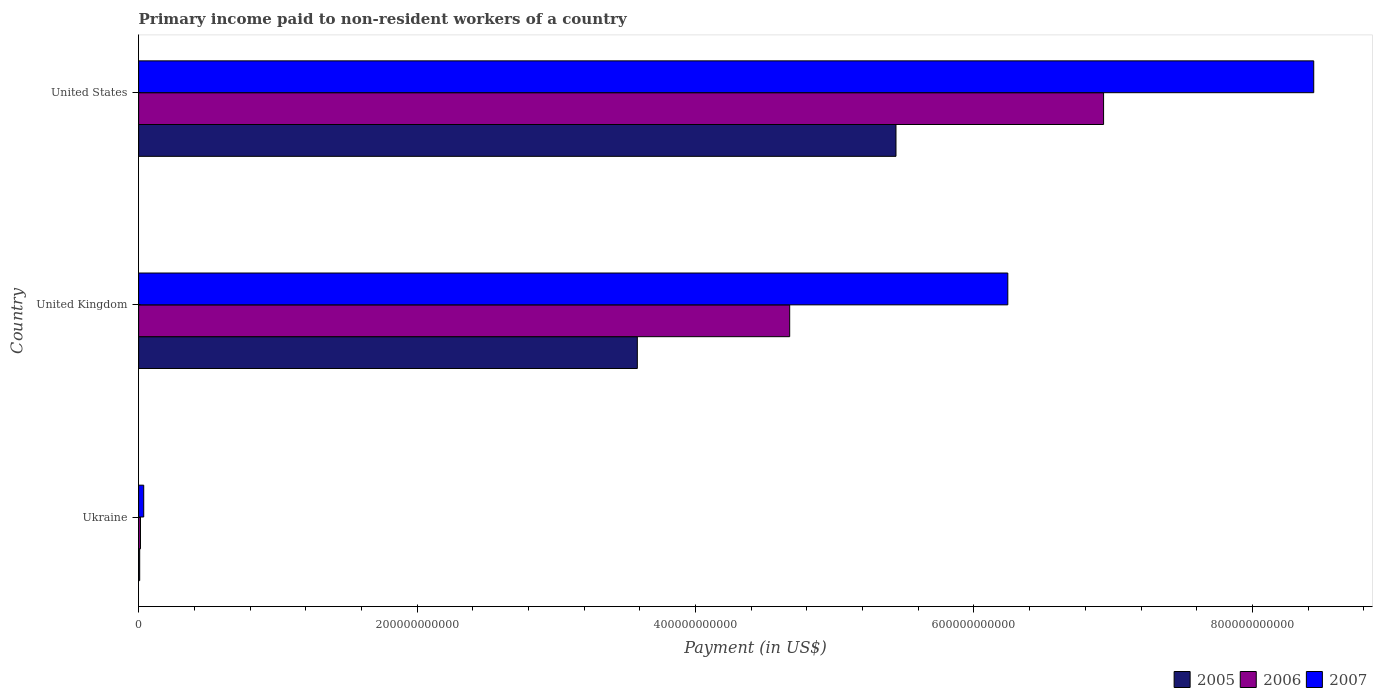How many different coloured bars are there?
Keep it short and to the point. 3. How many groups of bars are there?
Provide a short and direct response. 3. What is the label of the 2nd group of bars from the top?
Offer a very short reply. United Kingdom. What is the amount paid to workers in 2007 in United Kingdom?
Offer a terse response. 6.24e+11. Across all countries, what is the maximum amount paid to workers in 2007?
Your response must be concise. 8.44e+11. Across all countries, what is the minimum amount paid to workers in 2005?
Offer a terse response. 7.58e+08. In which country was the amount paid to workers in 2005 maximum?
Your answer should be compact. United States. In which country was the amount paid to workers in 2005 minimum?
Offer a very short reply. Ukraine. What is the total amount paid to workers in 2006 in the graph?
Make the answer very short. 1.16e+12. What is the difference between the amount paid to workers in 2006 in Ukraine and that in United Kingdom?
Your response must be concise. -4.66e+11. What is the difference between the amount paid to workers in 2007 in United Kingdom and the amount paid to workers in 2006 in Ukraine?
Make the answer very short. 6.23e+11. What is the average amount paid to workers in 2005 per country?
Provide a succinct answer. 3.01e+11. What is the difference between the amount paid to workers in 2006 and amount paid to workers in 2005 in Ukraine?
Offer a terse response. 5.74e+08. In how many countries, is the amount paid to workers in 2006 greater than 440000000000 US$?
Make the answer very short. 2. What is the ratio of the amount paid to workers in 2006 in United Kingdom to that in United States?
Provide a succinct answer. 0.67. Is the amount paid to workers in 2007 in Ukraine less than that in United States?
Make the answer very short. Yes. What is the difference between the highest and the second highest amount paid to workers in 2005?
Ensure brevity in your answer.  1.86e+11. What is the difference between the highest and the lowest amount paid to workers in 2007?
Provide a short and direct response. 8.40e+11. In how many countries, is the amount paid to workers in 2005 greater than the average amount paid to workers in 2005 taken over all countries?
Ensure brevity in your answer.  2. What does the 3rd bar from the top in United Kingdom represents?
Keep it short and to the point. 2005. What does the 3rd bar from the bottom in United Kingdom represents?
Offer a very short reply. 2007. Are all the bars in the graph horizontal?
Your response must be concise. Yes. How many countries are there in the graph?
Give a very brief answer. 3. What is the difference between two consecutive major ticks on the X-axis?
Give a very brief answer. 2.00e+11. Are the values on the major ticks of X-axis written in scientific E-notation?
Offer a very short reply. No. Does the graph contain grids?
Make the answer very short. No. Where does the legend appear in the graph?
Your answer should be compact. Bottom right. How many legend labels are there?
Provide a short and direct response. 3. How are the legend labels stacked?
Ensure brevity in your answer.  Horizontal. What is the title of the graph?
Give a very brief answer. Primary income paid to non-resident workers of a country. Does "1965" appear as one of the legend labels in the graph?
Offer a terse response. No. What is the label or title of the X-axis?
Give a very brief answer. Payment (in US$). What is the Payment (in US$) of 2005 in Ukraine?
Give a very brief answer. 7.58e+08. What is the Payment (in US$) of 2006 in Ukraine?
Offer a very short reply. 1.33e+09. What is the Payment (in US$) in 2007 in Ukraine?
Offer a terse response. 3.66e+09. What is the Payment (in US$) in 2005 in United Kingdom?
Your response must be concise. 3.58e+11. What is the Payment (in US$) in 2006 in United Kingdom?
Offer a terse response. 4.68e+11. What is the Payment (in US$) in 2007 in United Kingdom?
Offer a very short reply. 6.24e+11. What is the Payment (in US$) of 2005 in United States?
Your answer should be compact. 5.44e+11. What is the Payment (in US$) in 2006 in United States?
Keep it short and to the point. 6.93e+11. What is the Payment (in US$) of 2007 in United States?
Give a very brief answer. 8.44e+11. Across all countries, what is the maximum Payment (in US$) of 2005?
Your answer should be compact. 5.44e+11. Across all countries, what is the maximum Payment (in US$) in 2006?
Your response must be concise. 6.93e+11. Across all countries, what is the maximum Payment (in US$) of 2007?
Offer a terse response. 8.44e+11. Across all countries, what is the minimum Payment (in US$) in 2005?
Provide a succinct answer. 7.58e+08. Across all countries, what is the minimum Payment (in US$) of 2006?
Provide a short and direct response. 1.33e+09. Across all countries, what is the minimum Payment (in US$) in 2007?
Your answer should be compact. 3.66e+09. What is the total Payment (in US$) of 2005 in the graph?
Your response must be concise. 9.03e+11. What is the total Payment (in US$) of 2006 in the graph?
Make the answer very short. 1.16e+12. What is the total Payment (in US$) of 2007 in the graph?
Ensure brevity in your answer.  1.47e+12. What is the difference between the Payment (in US$) of 2005 in Ukraine and that in United Kingdom?
Ensure brevity in your answer.  -3.57e+11. What is the difference between the Payment (in US$) in 2006 in Ukraine and that in United Kingdom?
Provide a succinct answer. -4.66e+11. What is the difference between the Payment (in US$) in 2007 in Ukraine and that in United Kingdom?
Your answer should be very brief. -6.21e+11. What is the difference between the Payment (in US$) of 2005 in Ukraine and that in United States?
Your answer should be compact. -5.43e+11. What is the difference between the Payment (in US$) of 2006 in Ukraine and that in United States?
Provide a short and direct response. -6.92e+11. What is the difference between the Payment (in US$) in 2007 in Ukraine and that in United States?
Offer a very short reply. -8.40e+11. What is the difference between the Payment (in US$) in 2005 in United Kingdom and that in United States?
Provide a succinct answer. -1.86e+11. What is the difference between the Payment (in US$) in 2006 in United Kingdom and that in United States?
Give a very brief answer. -2.25e+11. What is the difference between the Payment (in US$) of 2007 in United Kingdom and that in United States?
Give a very brief answer. -2.20e+11. What is the difference between the Payment (in US$) of 2005 in Ukraine and the Payment (in US$) of 2006 in United Kingdom?
Offer a very short reply. -4.67e+11. What is the difference between the Payment (in US$) in 2005 in Ukraine and the Payment (in US$) in 2007 in United Kingdom?
Offer a very short reply. -6.24e+11. What is the difference between the Payment (in US$) in 2006 in Ukraine and the Payment (in US$) in 2007 in United Kingdom?
Offer a terse response. -6.23e+11. What is the difference between the Payment (in US$) of 2005 in Ukraine and the Payment (in US$) of 2006 in United States?
Provide a short and direct response. -6.92e+11. What is the difference between the Payment (in US$) of 2005 in Ukraine and the Payment (in US$) of 2007 in United States?
Your answer should be very brief. -8.43e+11. What is the difference between the Payment (in US$) of 2006 in Ukraine and the Payment (in US$) of 2007 in United States?
Offer a terse response. -8.43e+11. What is the difference between the Payment (in US$) in 2005 in United Kingdom and the Payment (in US$) in 2006 in United States?
Provide a succinct answer. -3.35e+11. What is the difference between the Payment (in US$) of 2005 in United Kingdom and the Payment (in US$) of 2007 in United States?
Offer a very short reply. -4.86e+11. What is the difference between the Payment (in US$) in 2006 in United Kingdom and the Payment (in US$) in 2007 in United States?
Provide a short and direct response. -3.76e+11. What is the average Payment (in US$) of 2005 per country?
Ensure brevity in your answer.  3.01e+11. What is the average Payment (in US$) in 2006 per country?
Give a very brief answer. 3.87e+11. What is the average Payment (in US$) in 2007 per country?
Your answer should be compact. 4.91e+11. What is the difference between the Payment (in US$) of 2005 and Payment (in US$) of 2006 in Ukraine?
Offer a very short reply. -5.74e+08. What is the difference between the Payment (in US$) in 2005 and Payment (in US$) in 2007 in Ukraine?
Offer a terse response. -2.90e+09. What is the difference between the Payment (in US$) in 2006 and Payment (in US$) in 2007 in Ukraine?
Provide a short and direct response. -2.32e+09. What is the difference between the Payment (in US$) of 2005 and Payment (in US$) of 2006 in United Kingdom?
Your answer should be compact. -1.09e+11. What is the difference between the Payment (in US$) of 2005 and Payment (in US$) of 2007 in United Kingdom?
Give a very brief answer. -2.66e+11. What is the difference between the Payment (in US$) of 2006 and Payment (in US$) of 2007 in United Kingdom?
Ensure brevity in your answer.  -1.57e+11. What is the difference between the Payment (in US$) of 2005 and Payment (in US$) of 2006 in United States?
Your answer should be very brief. -1.49e+11. What is the difference between the Payment (in US$) of 2005 and Payment (in US$) of 2007 in United States?
Provide a succinct answer. -3.00e+11. What is the difference between the Payment (in US$) of 2006 and Payment (in US$) of 2007 in United States?
Keep it short and to the point. -1.51e+11. What is the ratio of the Payment (in US$) of 2005 in Ukraine to that in United Kingdom?
Offer a terse response. 0. What is the ratio of the Payment (in US$) in 2006 in Ukraine to that in United Kingdom?
Give a very brief answer. 0. What is the ratio of the Payment (in US$) of 2007 in Ukraine to that in United Kingdom?
Offer a very short reply. 0.01. What is the ratio of the Payment (in US$) in 2005 in Ukraine to that in United States?
Give a very brief answer. 0. What is the ratio of the Payment (in US$) in 2006 in Ukraine to that in United States?
Your answer should be compact. 0. What is the ratio of the Payment (in US$) in 2007 in Ukraine to that in United States?
Keep it short and to the point. 0. What is the ratio of the Payment (in US$) in 2005 in United Kingdom to that in United States?
Keep it short and to the point. 0.66. What is the ratio of the Payment (in US$) in 2006 in United Kingdom to that in United States?
Offer a terse response. 0.67. What is the ratio of the Payment (in US$) in 2007 in United Kingdom to that in United States?
Provide a short and direct response. 0.74. What is the difference between the highest and the second highest Payment (in US$) in 2005?
Offer a very short reply. 1.86e+11. What is the difference between the highest and the second highest Payment (in US$) in 2006?
Offer a very short reply. 2.25e+11. What is the difference between the highest and the second highest Payment (in US$) of 2007?
Make the answer very short. 2.20e+11. What is the difference between the highest and the lowest Payment (in US$) in 2005?
Offer a very short reply. 5.43e+11. What is the difference between the highest and the lowest Payment (in US$) in 2006?
Provide a succinct answer. 6.92e+11. What is the difference between the highest and the lowest Payment (in US$) in 2007?
Provide a short and direct response. 8.40e+11. 